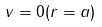<formula> <loc_0><loc_0><loc_500><loc_500>v = 0 ( r = a )</formula> 